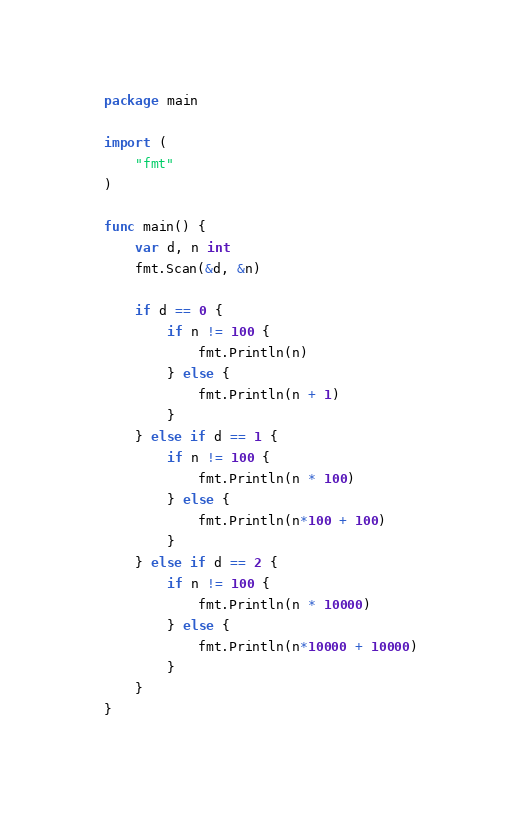<code> <loc_0><loc_0><loc_500><loc_500><_Go_>package main

import (
	"fmt"
)

func main() {
	var d, n int
	fmt.Scan(&d, &n)

	if d == 0 {
		if n != 100 {
			fmt.Println(n)
		} else {
			fmt.Println(n + 1)
		}
	} else if d == 1 {
		if n != 100 {
			fmt.Println(n * 100)
		} else {
			fmt.Println(n*100 + 100)
		}
	} else if d == 2 {
		if n != 100 {
			fmt.Println(n * 10000)
		} else {
			fmt.Println(n*10000 + 10000)
		}
	}
}
</code> 